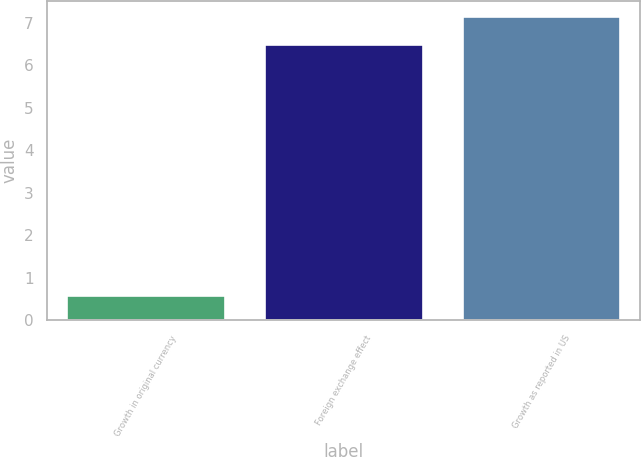<chart> <loc_0><loc_0><loc_500><loc_500><bar_chart><fcel>Growth in original currency<fcel>Foreign exchange effect<fcel>Growth as reported in US<nl><fcel>0.6<fcel>6.5<fcel>7.15<nl></chart> 